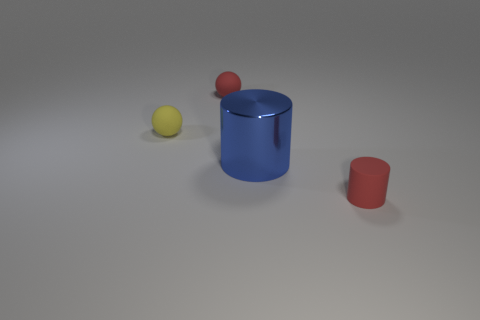Add 2 shiny objects. How many objects exist? 6 Add 1 yellow rubber things. How many yellow rubber things are left? 2 Add 1 tiny gray blocks. How many tiny gray blocks exist? 1 Subtract 0 blue blocks. How many objects are left? 4 Subtract all small spheres. Subtract all red rubber cylinders. How many objects are left? 1 